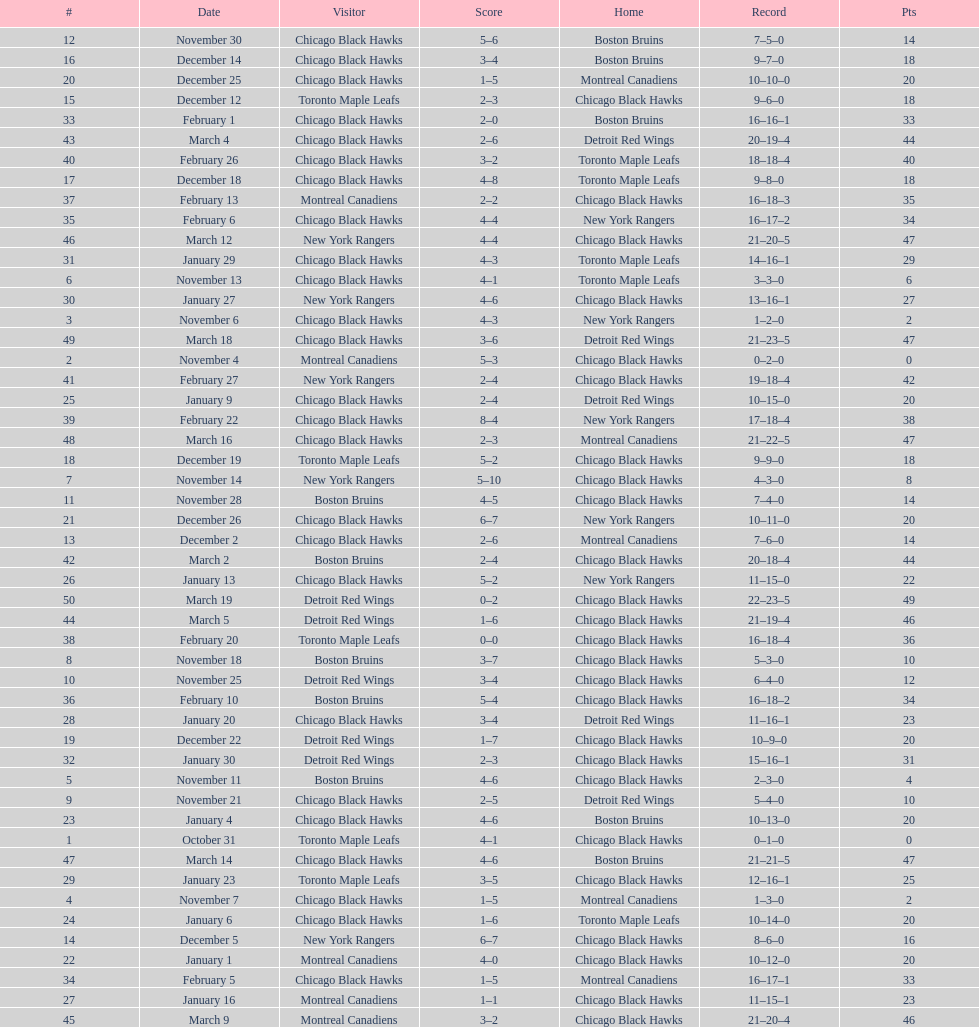How long is the duration of one season (from the first game to the last)? 5 months. 